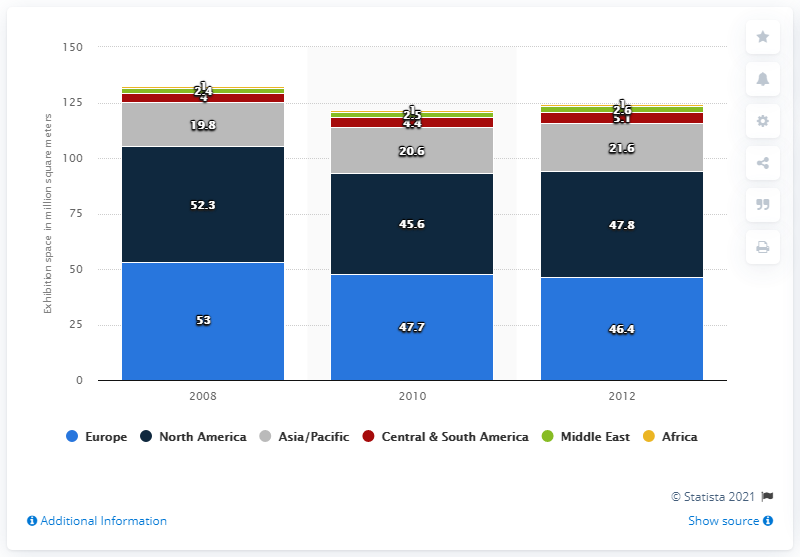Indicate a few pertinent items in this graphic. The venue exhibition space rented by Europe in 2008 was approximately 53 million square meters. In 2012, the Asia Pacific region rented a total of 21.6 square meters of exhibition space. In 2008, the difference between the light blue bar and the gray bar was the highest. 